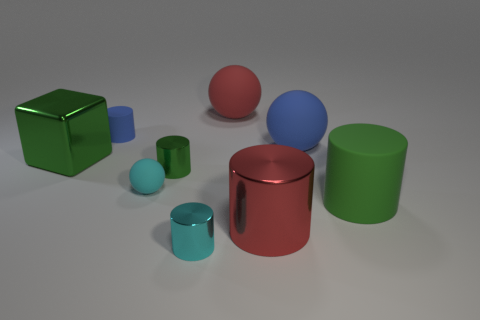Subtract all cyan cylinders. How many cylinders are left? 4 Subtract all large red cylinders. How many cylinders are left? 4 Subtract all brown cylinders. Subtract all yellow blocks. How many cylinders are left? 5 Subtract all blocks. How many objects are left? 8 Add 4 blue things. How many blue things are left? 6 Add 7 large yellow shiny cylinders. How many large yellow shiny cylinders exist? 7 Subtract 0 yellow cylinders. How many objects are left? 9 Subtract all blue cylinders. Subtract all big red spheres. How many objects are left? 7 